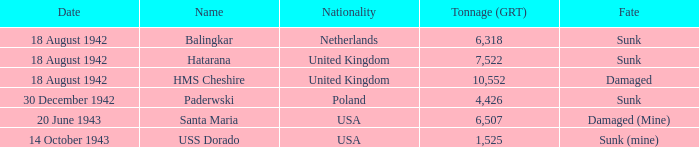What is the nationality of the HMS Cheshire? United Kingdom. 